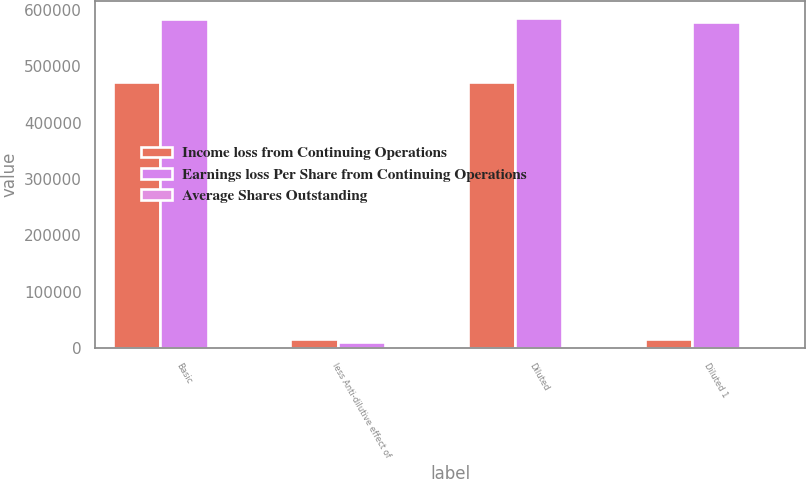Convert chart. <chart><loc_0><loc_0><loc_500><loc_500><stacked_bar_chart><ecel><fcel>Basic<fcel>less Anti-dilutive effect of<fcel>Diluted<fcel>Diluted 1<nl><fcel>Income loss from Continuing Operations<fcel>472557<fcel>15938<fcel>472557<fcel>15938<nl><fcel>Earnings loss Per Share from Continuing Operations<fcel>583904<fcel>10566<fcel>586491<fcel>578588<nl><fcel>Average Shares Outstanding<fcel>0.81<fcel>0.01<fcel>0.81<fcel>4.18<nl></chart> 